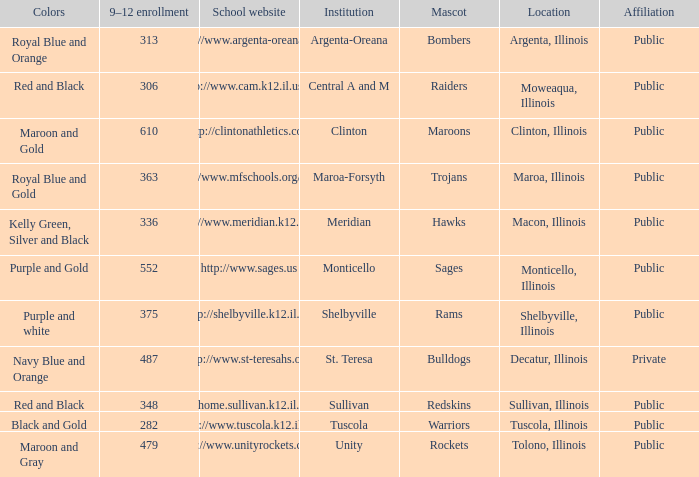Write the full table. {'header': ['Colors', '9–12 enrollment', 'School website', 'Institution', 'Mascot', 'Location', 'Affiliation'], 'rows': [['Royal Blue and Orange', '313', 'http://www.argenta-oreana.org', 'Argenta-Oreana', 'Bombers', 'Argenta, Illinois', 'Public'], ['Red and Black', '306', 'http://www.cam.k12.il.us/hs', 'Central A and M', 'Raiders', 'Moweaqua, Illinois', 'Public'], ['Maroon and Gold', '610', 'http://clintonathletics.com', 'Clinton', 'Maroons', 'Clinton, Illinois', 'Public'], ['Royal Blue and Gold', '363', 'http://www.mfschools.org/high/', 'Maroa-Forsyth', 'Trojans', 'Maroa, Illinois', 'Public'], ['Kelly Green, Silver and Black', '336', 'http://www.meridian.k12.il.us/', 'Meridian', 'Hawks', 'Macon, Illinois', 'Public'], ['Purple and Gold', '552', 'http://www.sages.us', 'Monticello', 'Sages', 'Monticello, Illinois', 'Public'], ['Purple and white', '375', 'http://shelbyville.k12.il.us/', 'Shelbyville', 'Rams', 'Shelbyville, Illinois', 'Public'], ['Navy Blue and Orange', '487', 'http://www.st-teresahs.org/', 'St. Teresa', 'Bulldogs', 'Decatur, Illinois', 'Private'], ['Red and Black', '348', 'http://home.sullivan.k12.il.us/shs', 'Sullivan', 'Redskins', 'Sullivan, Illinois', 'Public'], ['Black and Gold', '282', 'http://www.tuscola.k12.il.us/', 'Tuscola', 'Warriors', 'Tuscola, Illinois', 'Public'], ['Maroon and Gray', '479', 'http://www.unityrockets.com/', 'Unity', 'Rockets', 'Tolono, Illinois', 'Public']]} What are the team colors from Tolono, Illinois? Maroon and Gray. 